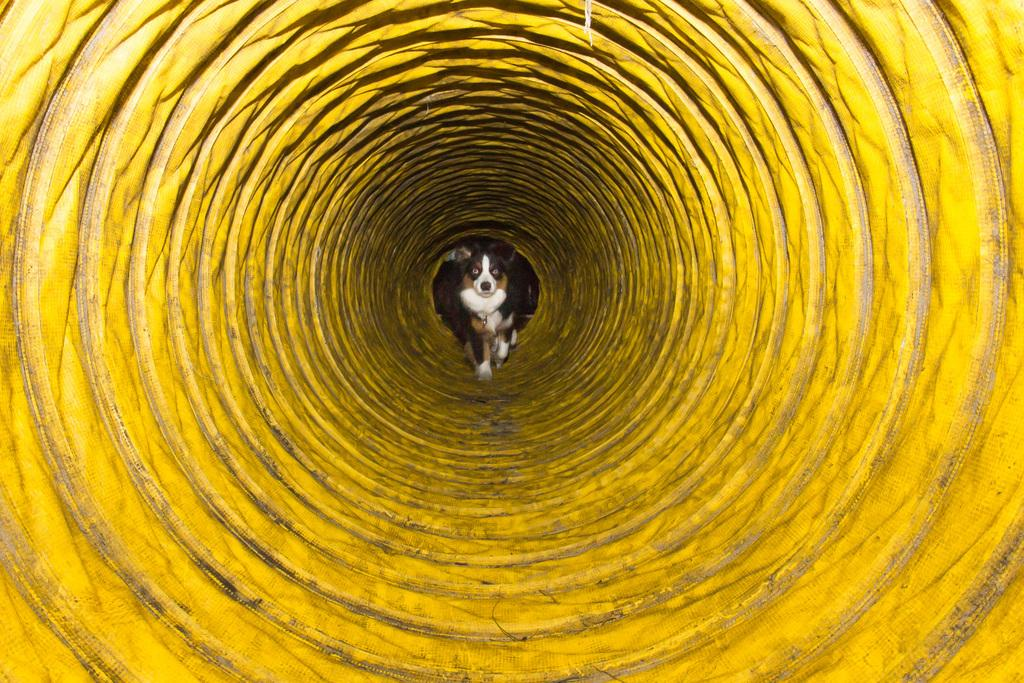What animal is in the picture? There is a dog in the picture. What is the dog doing in the picture? The dog is sitting. Where is the dog located in the picture? The dog is in a yellow-colored well. What type of authority does the deer have in the picture? There is no deer present in the picture; it features a dog sitting in a yellow-colored well. How is the knot tied around the dog's neck in the picture? There is no knot tied around the dog's neck in the picture; the dog is simply sitting in the well. 